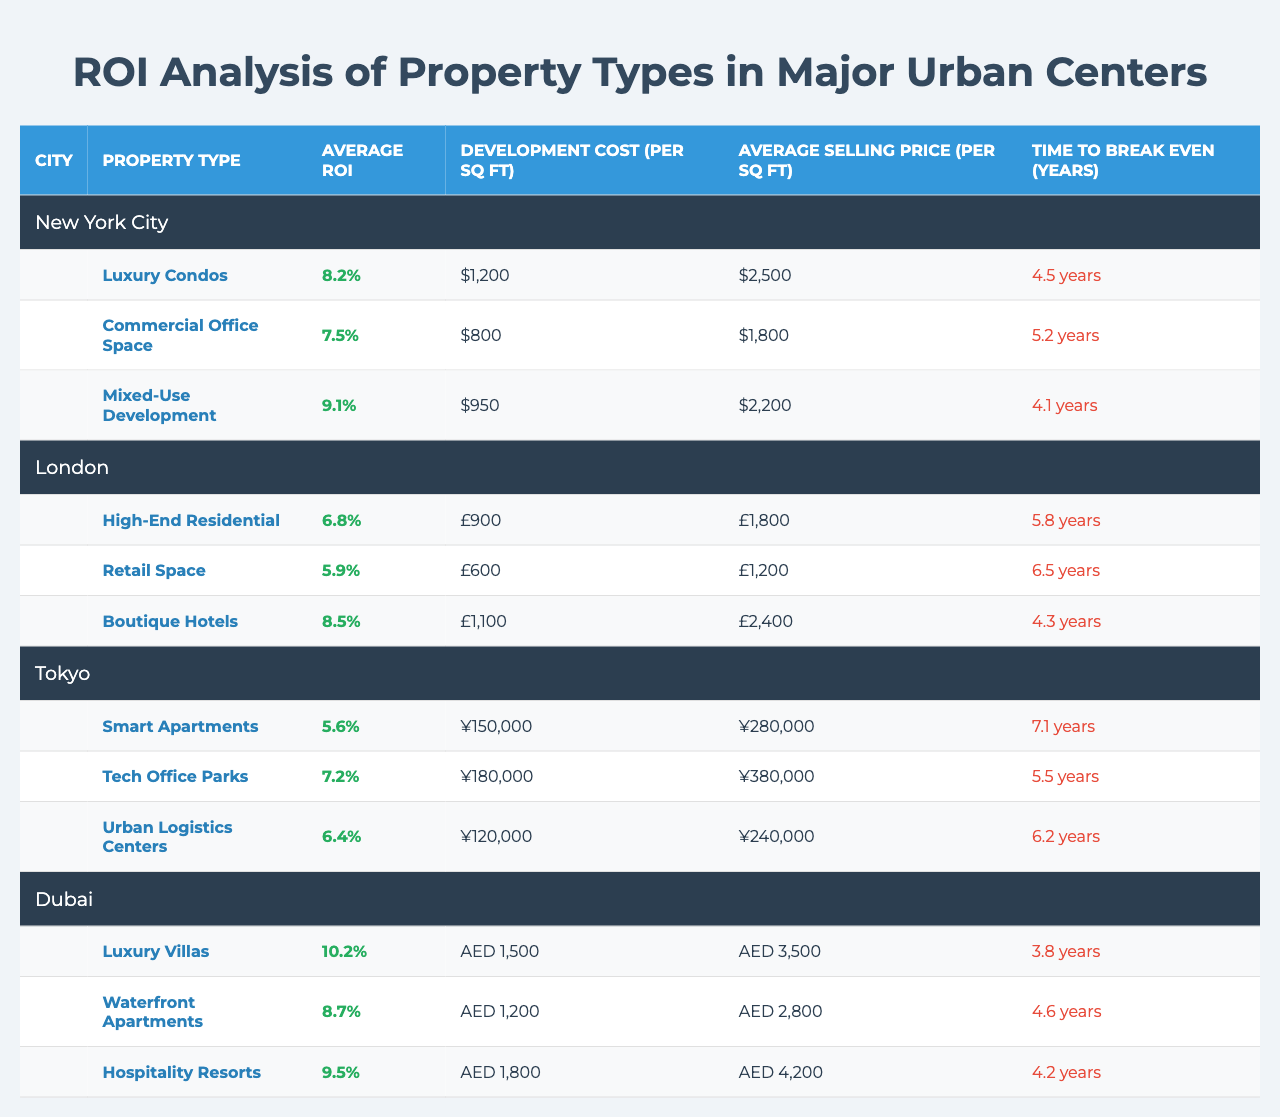What is the property type with the highest ROI in New York City? In New York City, the property types and their ROIs are: Luxury Condos (8.2%), Commercial Office Space (7.5%), and Mixed-Use Development (9.1%). The highest ROI among these is 9.1% from Mixed-Use Development.
Answer: Mixed-Use Development Which city has the lowest average ROI for its property types? The average ROIs for property types in each city are as follows: New York City (8.2%, 7.5%, 9.1%), London (6.8%, 5.9%, 8.5%), Tokyo (5.6%, 7.2%, 6.4%), and Dubai (10.2%, 8.7%, 9.5%). The lowest average ROI is 5.6% in Tokyo.
Answer: Tokyo What is the time to break even for Luxury Villas in Dubai? In the table, Luxury Villas in Dubai have a time to break even of 3.8 years.
Answer: 3.8 years Compare the average development cost per sq ft for Commercial Office Space in New York City and Retail Space in London. In New York City, the development cost for Commercial Office Space is $800 per sq ft, while in London, the development cost for Retail Space is £600 per sq ft. To directly compare, we can interpret the costs as they are without currency conversion as the question asks for a simple comparison. The New York City cost is higher.
Answer: Commercial Office Space is higher What is the difference in average ROI between the highest and lowest property types in London? The highest ROI in London is for Boutique Hotels at 8.5%, and the lowest is for Retail Space at 5.9%. To find the difference, we compute: 8.5% - 5.9% = 2.6%.
Answer: 2.6% In which city is the average selling price per sq ft highest for Luxury Villas and what is that price? The average selling price for Luxury Villas in Dubai is AED 3,500. The other cities do not have Luxury Villas listed, so Dubai is the only option here.
Answer: AED 3,500 How do the average selling prices for Smart Apartments in Tokyo and Luxury Condos in New York City compare? The average selling price for Smart Apartments in Tokyo is ¥280,000, and for Luxury Condos in New York City, it is $2,500 per sq ft. We cannot directly compare these without currency conversions, but since they are in different currencies, we cannot directly affirm which is higher without doing the conversion.
Answer: Cannot determine without conversion What is the average time to break even across all property types in New York City? The times to break even for New York City's property types are: 4.5 years for Luxury Condos, 5.2 years for Commercial Office Space, and 4.1 years for Mixed-Use Development. To find the average: (4.5 + 5.2 + 4.1) / 3 = 4.53 years.
Answer: 4.53 years Is the development cost per sq ft for Boutique Hotels in London higher than that for Luxury Villas in Dubai? The development cost for Boutique Hotels in London is £1,100, while for Luxury Villas in Dubai, it is AED 1,500. The answer cannot be definitively stated because the currencies are different, thus one cannot confirm without conversion.
Answer: Cannot determine without conversion What property type in Dubai has the shortest time to break even, and what is that time? In Dubai, the property types and their break-even times are: Luxury Villas (3.8 years), Waterfront Apartments (4.6 years), and Hospitality Resorts (4.2 years). The shortest time to break even is 3.8 years for Luxury Villas.
Answer: 3.8 years 